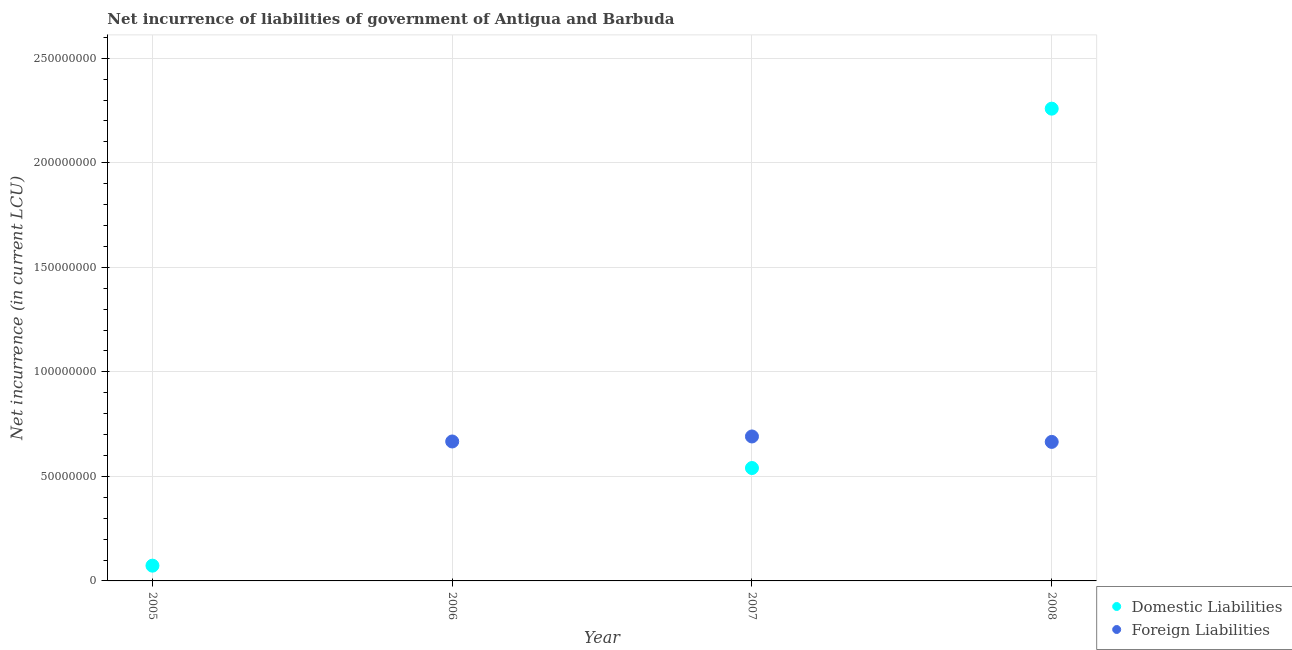How many different coloured dotlines are there?
Your answer should be compact. 2. Is the number of dotlines equal to the number of legend labels?
Provide a succinct answer. No. What is the net incurrence of domestic liabilities in 2005?
Give a very brief answer. 7.30e+06. Across all years, what is the maximum net incurrence of domestic liabilities?
Your response must be concise. 2.26e+08. What is the total net incurrence of domestic liabilities in the graph?
Make the answer very short. 2.87e+08. What is the difference between the net incurrence of foreign liabilities in 2006 and that in 2007?
Offer a terse response. -2.40e+06. What is the difference between the net incurrence of foreign liabilities in 2006 and the net incurrence of domestic liabilities in 2008?
Your answer should be compact. -1.59e+08. What is the average net incurrence of domestic liabilities per year?
Your answer should be very brief. 7.18e+07. In the year 2008, what is the difference between the net incurrence of domestic liabilities and net incurrence of foreign liabilities?
Your response must be concise. 1.59e+08. What is the ratio of the net incurrence of domestic liabilities in 2007 to that in 2008?
Provide a succinct answer. 0.24. What is the difference between the highest and the second highest net incurrence of domestic liabilities?
Your response must be concise. 1.72e+08. What is the difference between the highest and the lowest net incurrence of domestic liabilities?
Keep it short and to the point. 2.26e+08. In how many years, is the net incurrence of foreign liabilities greater than the average net incurrence of foreign liabilities taken over all years?
Provide a short and direct response. 3. Does the net incurrence of foreign liabilities monotonically increase over the years?
Make the answer very short. No. Is the net incurrence of domestic liabilities strictly greater than the net incurrence of foreign liabilities over the years?
Provide a short and direct response. No. Is the net incurrence of domestic liabilities strictly less than the net incurrence of foreign liabilities over the years?
Offer a terse response. No. How many years are there in the graph?
Offer a very short reply. 4. What is the difference between two consecutive major ticks on the Y-axis?
Offer a very short reply. 5.00e+07. Does the graph contain any zero values?
Make the answer very short. Yes. Does the graph contain grids?
Your response must be concise. Yes. Where does the legend appear in the graph?
Give a very brief answer. Bottom right. How many legend labels are there?
Your answer should be compact. 2. What is the title of the graph?
Provide a short and direct response. Net incurrence of liabilities of government of Antigua and Barbuda. What is the label or title of the X-axis?
Give a very brief answer. Year. What is the label or title of the Y-axis?
Give a very brief answer. Net incurrence (in current LCU). What is the Net incurrence (in current LCU) in Domestic Liabilities in 2005?
Offer a terse response. 7.30e+06. What is the Net incurrence (in current LCU) of Foreign Liabilities in 2006?
Offer a terse response. 6.67e+07. What is the Net incurrence (in current LCU) in Domestic Liabilities in 2007?
Keep it short and to the point. 5.40e+07. What is the Net incurrence (in current LCU) in Foreign Liabilities in 2007?
Your response must be concise. 6.91e+07. What is the Net incurrence (in current LCU) of Domestic Liabilities in 2008?
Provide a succinct answer. 2.26e+08. What is the Net incurrence (in current LCU) in Foreign Liabilities in 2008?
Offer a very short reply. 6.65e+07. Across all years, what is the maximum Net incurrence (in current LCU) of Domestic Liabilities?
Your answer should be very brief. 2.26e+08. Across all years, what is the maximum Net incurrence (in current LCU) of Foreign Liabilities?
Give a very brief answer. 6.91e+07. Across all years, what is the minimum Net incurrence (in current LCU) of Domestic Liabilities?
Offer a very short reply. 0. Across all years, what is the minimum Net incurrence (in current LCU) of Foreign Liabilities?
Provide a short and direct response. 0. What is the total Net incurrence (in current LCU) of Domestic Liabilities in the graph?
Your response must be concise. 2.87e+08. What is the total Net incurrence (in current LCU) in Foreign Liabilities in the graph?
Provide a short and direct response. 2.02e+08. What is the difference between the Net incurrence (in current LCU) in Domestic Liabilities in 2005 and that in 2007?
Offer a very short reply. -4.67e+07. What is the difference between the Net incurrence (in current LCU) of Domestic Liabilities in 2005 and that in 2008?
Your answer should be very brief. -2.19e+08. What is the difference between the Net incurrence (in current LCU) in Foreign Liabilities in 2006 and that in 2007?
Your answer should be very brief. -2.40e+06. What is the difference between the Net incurrence (in current LCU) in Domestic Liabilities in 2007 and that in 2008?
Ensure brevity in your answer.  -1.72e+08. What is the difference between the Net incurrence (in current LCU) of Foreign Liabilities in 2007 and that in 2008?
Keep it short and to the point. 2.60e+06. What is the difference between the Net incurrence (in current LCU) in Domestic Liabilities in 2005 and the Net incurrence (in current LCU) in Foreign Liabilities in 2006?
Your answer should be very brief. -5.94e+07. What is the difference between the Net incurrence (in current LCU) of Domestic Liabilities in 2005 and the Net incurrence (in current LCU) of Foreign Liabilities in 2007?
Your answer should be very brief. -6.18e+07. What is the difference between the Net incurrence (in current LCU) in Domestic Liabilities in 2005 and the Net incurrence (in current LCU) in Foreign Liabilities in 2008?
Your answer should be compact. -5.92e+07. What is the difference between the Net incurrence (in current LCU) of Domestic Liabilities in 2007 and the Net incurrence (in current LCU) of Foreign Liabilities in 2008?
Give a very brief answer. -1.25e+07. What is the average Net incurrence (in current LCU) of Domestic Liabilities per year?
Offer a terse response. 7.18e+07. What is the average Net incurrence (in current LCU) of Foreign Liabilities per year?
Offer a very short reply. 5.06e+07. In the year 2007, what is the difference between the Net incurrence (in current LCU) of Domestic Liabilities and Net incurrence (in current LCU) of Foreign Liabilities?
Provide a succinct answer. -1.51e+07. In the year 2008, what is the difference between the Net incurrence (in current LCU) of Domestic Liabilities and Net incurrence (in current LCU) of Foreign Liabilities?
Keep it short and to the point. 1.59e+08. What is the ratio of the Net incurrence (in current LCU) in Domestic Liabilities in 2005 to that in 2007?
Make the answer very short. 0.14. What is the ratio of the Net incurrence (in current LCU) in Domestic Liabilities in 2005 to that in 2008?
Provide a short and direct response. 0.03. What is the ratio of the Net incurrence (in current LCU) in Foreign Liabilities in 2006 to that in 2007?
Make the answer very short. 0.97. What is the ratio of the Net incurrence (in current LCU) in Foreign Liabilities in 2006 to that in 2008?
Make the answer very short. 1. What is the ratio of the Net incurrence (in current LCU) of Domestic Liabilities in 2007 to that in 2008?
Your response must be concise. 0.24. What is the ratio of the Net incurrence (in current LCU) in Foreign Liabilities in 2007 to that in 2008?
Offer a terse response. 1.04. What is the difference between the highest and the second highest Net incurrence (in current LCU) of Domestic Liabilities?
Ensure brevity in your answer.  1.72e+08. What is the difference between the highest and the second highest Net incurrence (in current LCU) of Foreign Liabilities?
Provide a short and direct response. 2.40e+06. What is the difference between the highest and the lowest Net incurrence (in current LCU) of Domestic Liabilities?
Ensure brevity in your answer.  2.26e+08. What is the difference between the highest and the lowest Net incurrence (in current LCU) of Foreign Liabilities?
Give a very brief answer. 6.91e+07. 